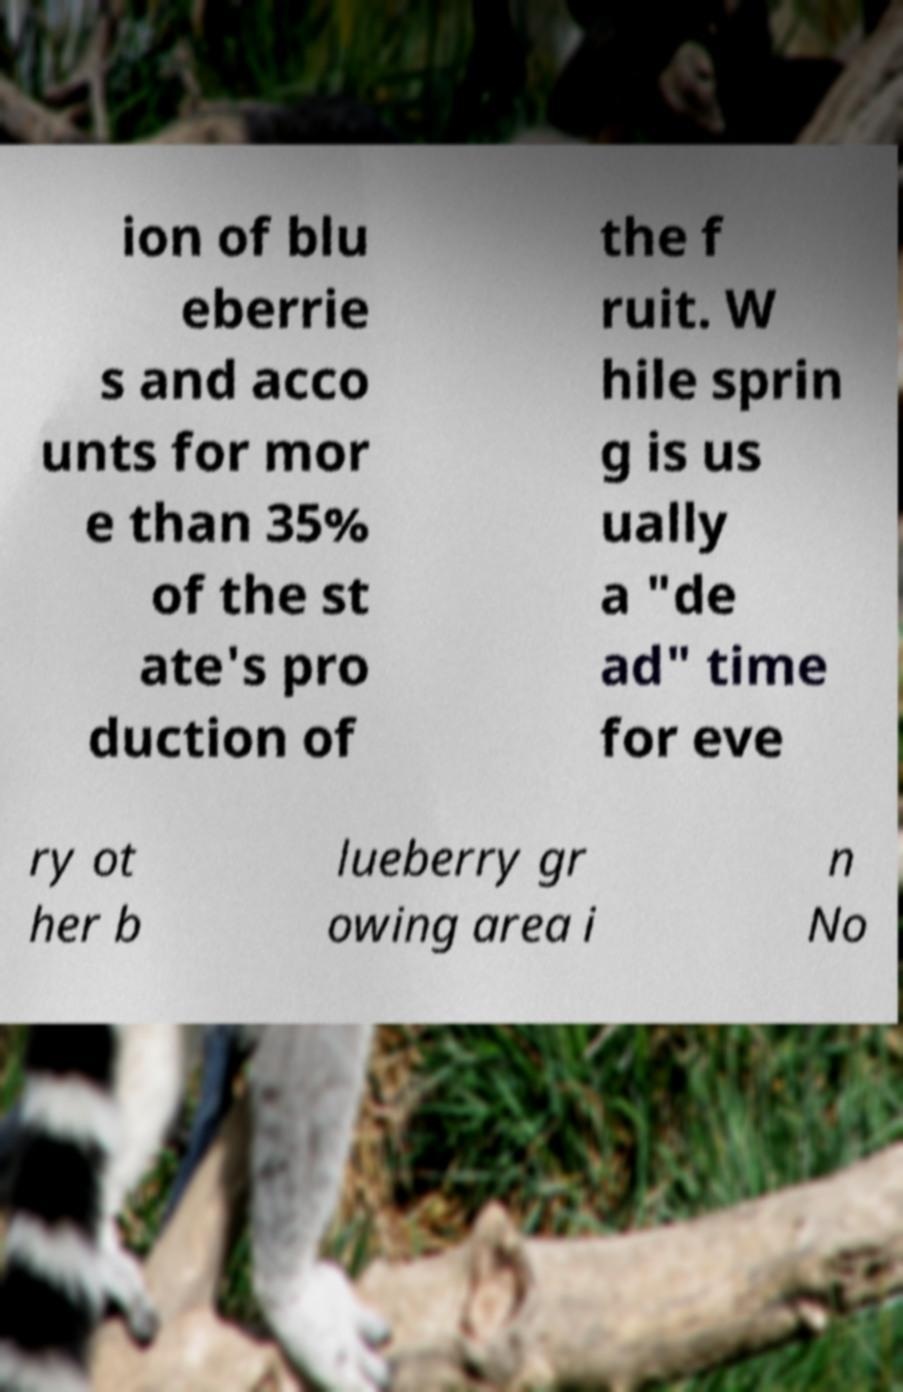Can you read and provide the text displayed in the image?This photo seems to have some interesting text. Can you extract and type it out for me? ion of blu eberrie s and acco unts for mor e than 35% of the st ate's pro duction of the f ruit. W hile sprin g is us ually a "de ad" time for eve ry ot her b lueberry gr owing area i n No 